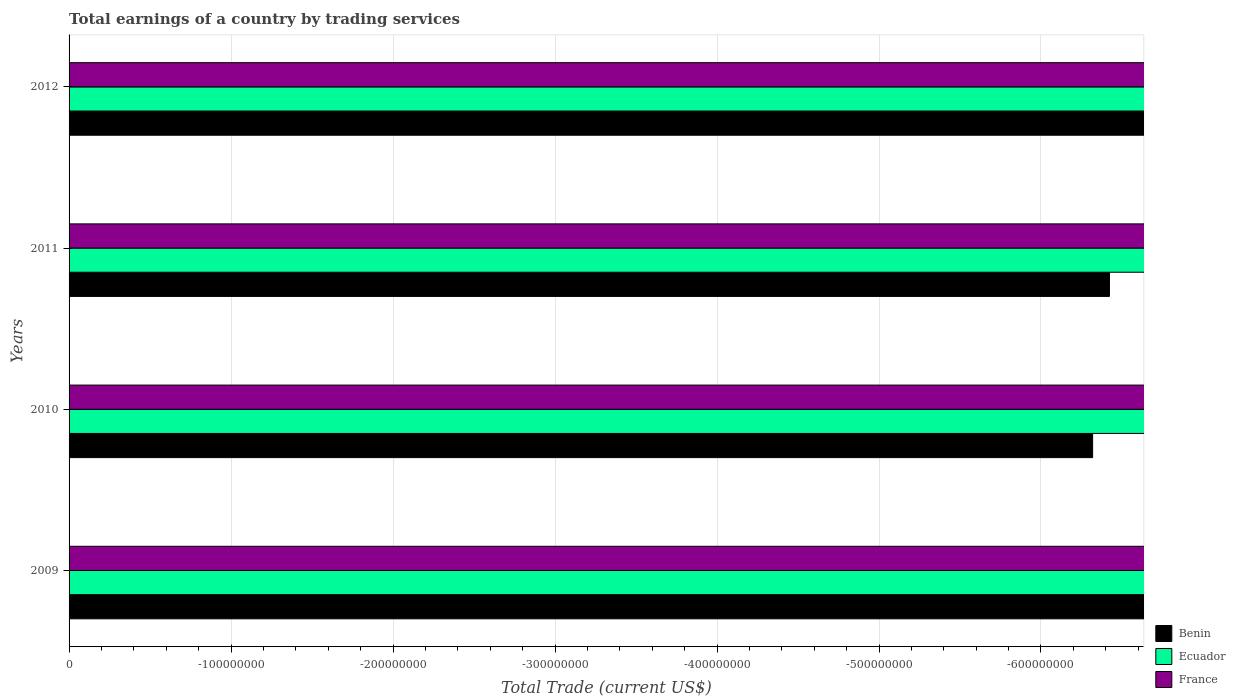Are the number of bars per tick equal to the number of legend labels?
Offer a very short reply. No. Are the number of bars on each tick of the Y-axis equal?
Your response must be concise. Yes. How many bars are there on the 3rd tick from the top?
Make the answer very short. 0. How many bars are there on the 3rd tick from the bottom?
Your answer should be very brief. 0. In how many cases, is the number of bars for a given year not equal to the number of legend labels?
Ensure brevity in your answer.  4. Across all years, what is the minimum total earnings in France?
Offer a very short reply. 0. What is the total total earnings in Ecuador in the graph?
Your answer should be very brief. 0. What is the average total earnings in Benin per year?
Provide a succinct answer. 0. In how many years, is the total earnings in Benin greater than -340000000 US$?
Keep it short and to the point. 0. In how many years, is the total earnings in Ecuador greater than the average total earnings in Ecuador taken over all years?
Give a very brief answer. 0. Is it the case that in every year, the sum of the total earnings in France and total earnings in Benin is greater than the total earnings in Ecuador?
Your answer should be very brief. No. How many years are there in the graph?
Keep it short and to the point. 4. What is the difference between two consecutive major ticks on the X-axis?
Your answer should be very brief. 1.00e+08. Does the graph contain grids?
Your answer should be compact. Yes. What is the title of the graph?
Provide a short and direct response. Total earnings of a country by trading services. Does "Myanmar" appear as one of the legend labels in the graph?
Ensure brevity in your answer.  No. What is the label or title of the X-axis?
Provide a short and direct response. Total Trade (current US$). What is the Total Trade (current US$) in Ecuador in 2009?
Provide a short and direct response. 0. What is the Total Trade (current US$) in Benin in 2010?
Provide a succinct answer. 0. What is the Total Trade (current US$) of Ecuador in 2010?
Give a very brief answer. 0. What is the Total Trade (current US$) of France in 2010?
Give a very brief answer. 0. What is the Total Trade (current US$) of Benin in 2011?
Ensure brevity in your answer.  0. What is the Total Trade (current US$) of France in 2012?
Your response must be concise. 0. What is the total Total Trade (current US$) in Benin in the graph?
Make the answer very short. 0. What is the total Total Trade (current US$) of Ecuador in the graph?
Ensure brevity in your answer.  0. What is the average Total Trade (current US$) in Benin per year?
Your answer should be compact. 0. 